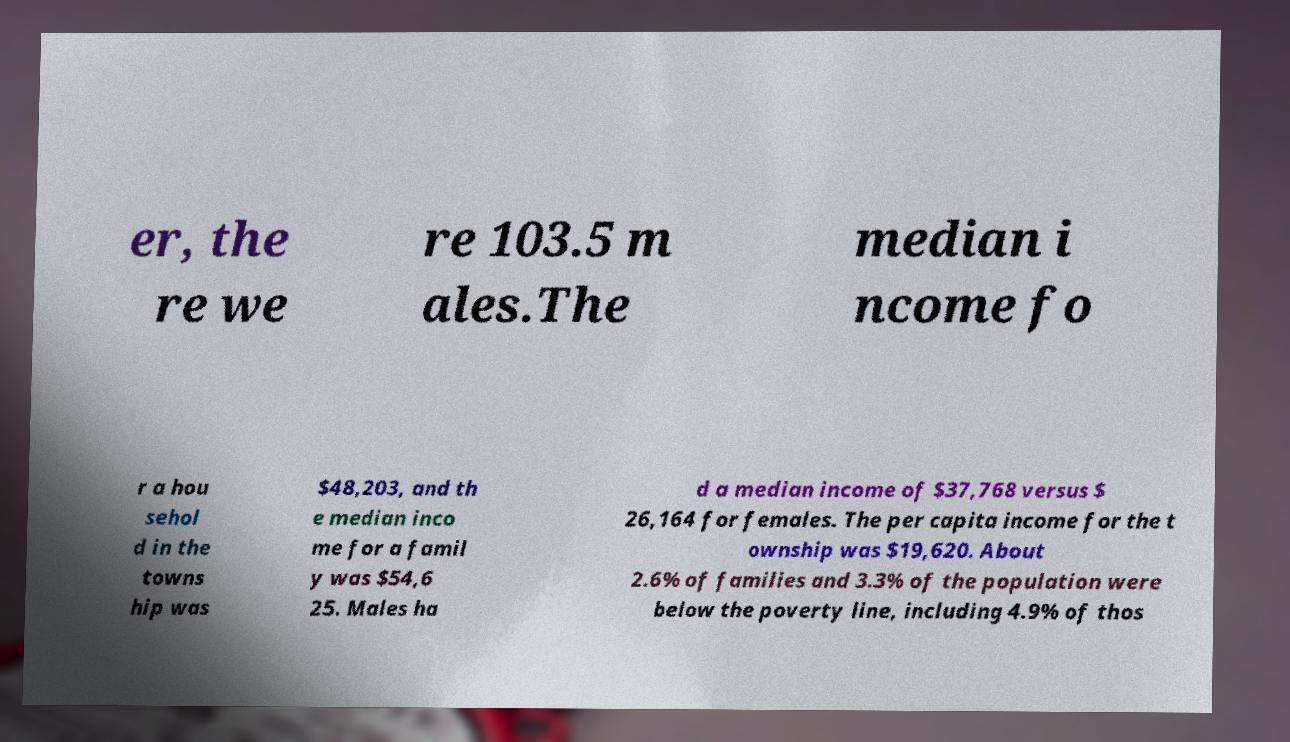For documentation purposes, I need the text within this image transcribed. Could you provide that? er, the re we re 103.5 m ales.The median i ncome fo r a hou sehol d in the towns hip was $48,203, and th e median inco me for a famil y was $54,6 25. Males ha d a median income of $37,768 versus $ 26,164 for females. The per capita income for the t ownship was $19,620. About 2.6% of families and 3.3% of the population were below the poverty line, including 4.9% of thos 